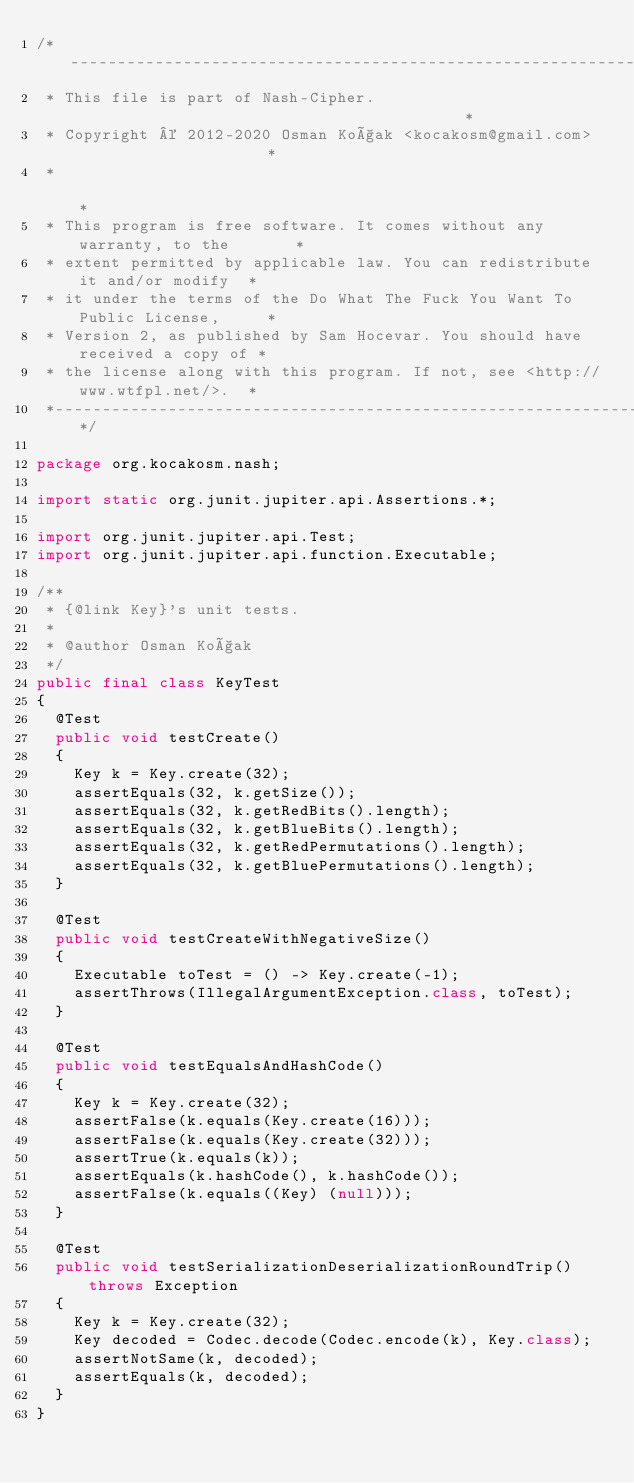<code> <loc_0><loc_0><loc_500><loc_500><_Java_>/*----------------------------------------------------------------------------*
 * This file is part of Nash-Cipher.                                          *
 * Copyright © 2012-2020 Osman Koçak <kocakosm@gmail.com>                     *
 *                                                                            *
 * This program is free software. It comes without any warranty, to the       *
 * extent permitted by applicable law. You can redistribute it and/or modify  *
 * it under the terms of the Do What The Fuck You Want To Public License,     *
 * Version 2, as published by Sam Hocevar. You should have received a copy of *
 * the license along with this program. If not, see <http://www.wtfpl.net/>.  *
 *----------------------------------------------------------------------------*/

package org.kocakosm.nash;

import static org.junit.jupiter.api.Assertions.*;

import org.junit.jupiter.api.Test;
import org.junit.jupiter.api.function.Executable;

/**
 * {@link Key}'s unit tests.
 *
 * @author Osman Koçak
 */
public final class KeyTest
{
	@Test
	public void testCreate()
	{
		Key k = Key.create(32);
		assertEquals(32, k.getSize());
		assertEquals(32, k.getRedBits().length);
		assertEquals(32, k.getBlueBits().length);
		assertEquals(32, k.getRedPermutations().length);
		assertEquals(32, k.getBluePermutations().length);
	}

	@Test
	public void testCreateWithNegativeSize()
	{
		Executable toTest = () -> Key.create(-1);
		assertThrows(IllegalArgumentException.class, toTest);
	}

	@Test
	public void testEqualsAndHashCode()
	{
		Key k = Key.create(32);
		assertFalse(k.equals(Key.create(16)));
		assertFalse(k.equals(Key.create(32)));
		assertTrue(k.equals(k));
		assertEquals(k.hashCode(), k.hashCode());
		assertFalse(k.equals((Key) (null)));
	}

	@Test
	public void testSerializationDeserializationRoundTrip() throws Exception
	{
		Key k = Key.create(32);
		Key decoded = Codec.decode(Codec.encode(k), Key.class);
		assertNotSame(k, decoded);
		assertEquals(k, decoded);
	}
}
</code> 